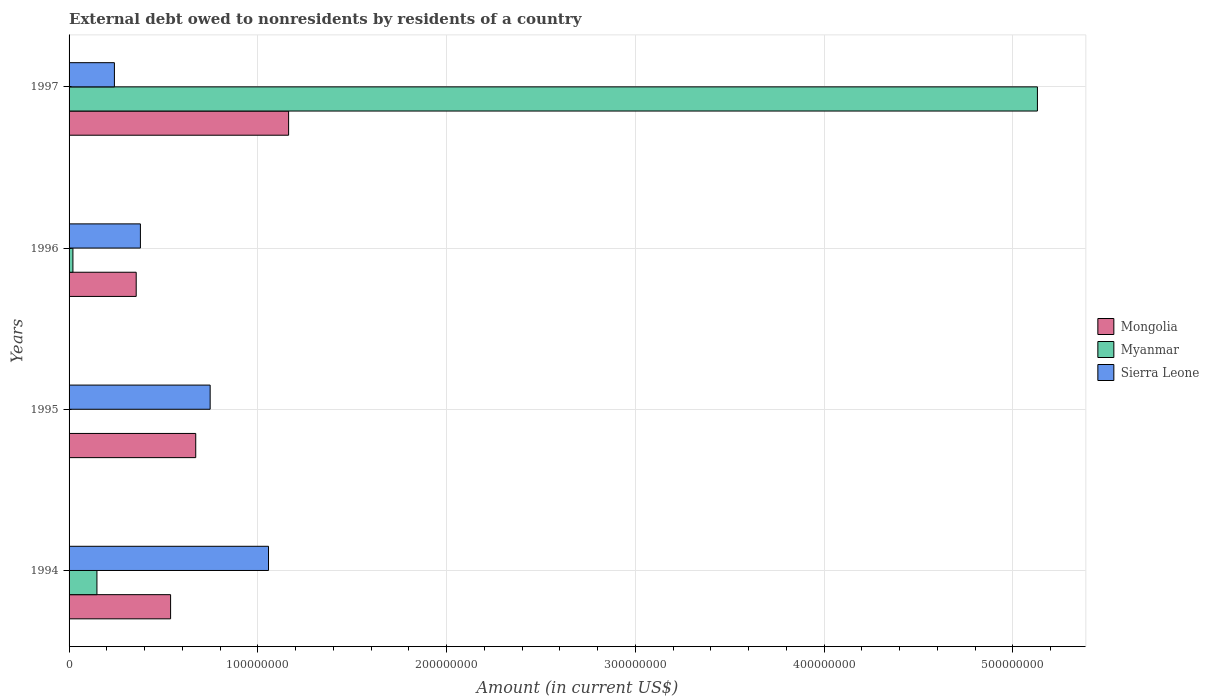How many different coloured bars are there?
Your answer should be compact. 3. What is the external debt owed by residents in Mongolia in 1994?
Give a very brief answer. 5.38e+07. Across all years, what is the maximum external debt owed by residents in Myanmar?
Provide a short and direct response. 5.13e+08. Across all years, what is the minimum external debt owed by residents in Mongolia?
Make the answer very short. 3.56e+07. What is the total external debt owed by residents in Myanmar in the graph?
Your answer should be very brief. 5.30e+08. What is the difference between the external debt owed by residents in Mongolia in 1995 and that in 1997?
Keep it short and to the point. -4.92e+07. What is the difference between the external debt owed by residents in Mongolia in 1996 and the external debt owed by residents in Myanmar in 1997?
Keep it short and to the point. -4.77e+08. What is the average external debt owed by residents in Mongolia per year?
Ensure brevity in your answer.  6.82e+07. In the year 1997, what is the difference between the external debt owed by residents in Sierra Leone and external debt owed by residents in Myanmar?
Provide a short and direct response. -4.89e+08. What is the ratio of the external debt owed by residents in Sierra Leone in 1995 to that in 1997?
Make the answer very short. 3.11. What is the difference between the highest and the second highest external debt owed by residents in Myanmar?
Keep it short and to the point. 4.98e+08. What is the difference between the highest and the lowest external debt owed by residents in Myanmar?
Offer a terse response. 5.13e+08. In how many years, is the external debt owed by residents in Mongolia greater than the average external debt owed by residents in Mongolia taken over all years?
Your response must be concise. 1. Is the sum of the external debt owed by residents in Myanmar in 1994 and 1997 greater than the maximum external debt owed by residents in Sierra Leone across all years?
Your answer should be compact. Yes. Is it the case that in every year, the sum of the external debt owed by residents in Mongolia and external debt owed by residents in Myanmar is greater than the external debt owed by residents in Sierra Leone?
Keep it short and to the point. No. How many bars are there?
Keep it short and to the point. 11. Are all the bars in the graph horizontal?
Make the answer very short. Yes. What is the difference between two consecutive major ticks on the X-axis?
Offer a terse response. 1.00e+08. Does the graph contain grids?
Your response must be concise. Yes. What is the title of the graph?
Offer a terse response. External debt owed to nonresidents by residents of a country. Does "South Sudan" appear as one of the legend labels in the graph?
Provide a succinct answer. No. What is the label or title of the X-axis?
Make the answer very short. Amount (in current US$). What is the label or title of the Y-axis?
Provide a succinct answer. Years. What is the Amount (in current US$) in Mongolia in 1994?
Your response must be concise. 5.38e+07. What is the Amount (in current US$) in Myanmar in 1994?
Offer a very short reply. 1.48e+07. What is the Amount (in current US$) of Sierra Leone in 1994?
Make the answer very short. 1.06e+08. What is the Amount (in current US$) in Mongolia in 1995?
Offer a very short reply. 6.71e+07. What is the Amount (in current US$) in Sierra Leone in 1995?
Your answer should be very brief. 7.47e+07. What is the Amount (in current US$) of Mongolia in 1996?
Your response must be concise. 3.56e+07. What is the Amount (in current US$) of Myanmar in 1996?
Offer a very short reply. 2.04e+06. What is the Amount (in current US$) in Sierra Leone in 1996?
Your response must be concise. 3.78e+07. What is the Amount (in current US$) of Mongolia in 1997?
Your answer should be very brief. 1.16e+08. What is the Amount (in current US$) of Myanmar in 1997?
Your answer should be very brief. 5.13e+08. What is the Amount (in current US$) of Sierra Leone in 1997?
Give a very brief answer. 2.40e+07. Across all years, what is the maximum Amount (in current US$) in Mongolia?
Your answer should be compact. 1.16e+08. Across all years, what is the maximum Amount (in current US$) in Myanmar?
Ensure brevity in your answer.  5.13e+08. Across all years, what is the maximum Amount (in current US$) in Sierra Leone?
Give a very brief answer. 1.06e+08. Across all years, what is the minimum Amount (in current US$) in Mongolia?
Offer a terse response. 3.56e+07. Across all years, what is the minimum Amount (in current US$) of Myanmar?
Offer a very short reply. 0. Across all years, what is the minimum Amount (in current US$) in Sierra Leone?
Provide a succinct answer. 2.40e+07. What is the total Amount (in current US$) of Mongolia in the graph?
Ensure brevity in your answer.  2.73e+08. What is the total Amount (in current US$) of Myanmar in the graph?
Offer a terse response. 5.30e+08. What is the total Amount (in current US$) in Sierra Leone in the graph?
Your response must be concise. 2.42e+08. What is the difference between the Amount (in current US$) of Mongolia in 1994 and that in 1995?
Give a very brief answer. -1.33e+07. What is the difference between the Amount (in current US$) of Sierra Leone in 1994 and that in 1995?
Offer a very short reply. 3.09e+07. What is the difference between the Amount (in current US$) in Mongolia in 1994 and that in 1996?
Make the answer very short. 1.82e+07. What is the difference between the Amount (in current US$) of Myanmar in 1994 and that in 1996?
Provide a short and direct response. 1.27e+07. What is the difference between the Amount (in current US$) of Sierra Leone in 1994 and that in 1996?
Provide a short and direct response. 6.79e+07. What is the difference between the Amount (in current US$) of Mongolia in 1994 and that in 1997?
Provide a succinct answer. -6.25e+07. What is the difference between the Amount (in current US$) of Myanmar in 1994 and that in 1997?
Offer a very short reply. -4.98e+08. What is the difference between the Amount (in current US$) in Sierra Leone in 1994 and that in 1997?
Keep it short and to the point. 8.16e+07. What is the difference between the Amount (in current US$) in Mongolia in 1995 and that in 1996?
Give a very brief answer. 3.15e+07. What is the difference between the Amount (in current US$) in Sierra Leone in 1995 and that in 1996?
Offer a very short reply. 3.69e+07. What is the difference between the Amount (in current US$) of Mongolia in 1995 and that in 1997?
Ensure brevity in your answer.  -4.92e+07. What is the difference between the Amount (in current US$) of Sierra Leone in 1995 and that in 1997?
Make the answer very short. 5.07e+07. What is the difference between the Amount (in current US$) of Mongolia in 1996 and that in 1997?
Make the answer very short. -8.07e+07. What is the difference between the Amount (in current US$) in Myanmar in 1996 and that in 1997?
Your answer should be very brief. -5.11e+08. What is the difference between the Amount (in current US$) of Sierra Leone in 1996 and that in 1997?
Your response must be concise. 1.38e+07. What is the difference between the Amount (in current US$) in Mongolia in 1994 and the Amount (in current US$) in Sierra Leone in 1995?
Provide a short and direct response. -2.10e+07. What is the difference between the Amount (in current US$) in Myanmar in 1994 and the Amount (in current US$) in Sierra Leone in 1995?
Ensure brevity in your answer.  -6.00e+07. What is the difference between the Amount (in current US$) of Mongolia in 1994 and the Amount (in current US$) of Myanmar in 1996?
Offer a terse response. 5.17e+07. What is the difference between the Amount (in current US$) of Mongolia in 1994 and the Amount (in current US$) of Sierra Leone in 1996?
Offer a terse response. 1.60e+07. What is the difference between the Amount (in current US$) of Myanmar in 1994 and the Amount (in current US$) of Sierra Leone in 1996?
Ensure brevity in your answer.  -2.30e+07. What is the difference between the Amount (in current US$) in Mongolia in 1994 and the Amount (in current US$) in Myanmar in 1997?
Keep it short and to the point. -4.59e+08. What is the difference between the Amount (in current US$) in Mongolia in 1994 and the Amount (in current US$) in Sierra Leone in 1997?
Ensure brevity in your answer.  2.98e+07. What is the difference between the Amount (in current US$) in Myanmar in 1994 and the Amount (in current US$) in Sierra Leone in 1997?
Provide a succinct answer. -9.25e+06. What is the difference between the Amount (in current US$) of Mongolia in 1995 and the Amount (in current US$) of Myanmar in 1996?
Your response must be concise. 6.51e+07. What is the difference between the Amount (in current US$) of Mongolia in 1995 and the Amount (in current US$) of Sierra Leone in 1996?
Offer a very short reply. 2.93e+07. What is the difference between the Amount (in current US$) in Mongolia in 1995 and the Amount (in current US$) in Myanmar in 1997?
Give a very brief answer. -4.46e+08. What is the difference between the Amount (in current US$) of Mongolia in 1995 and the Amount (in current US$) of Sierra Leone in 1997?
Provide a succinct answer. 4.31e+07. What is the difference between the Amount (in current US$) in Mongolia in 1996 and the Amount (in current US$) in Myanmar in 1997?
Make the answer very short. -4.77e+08. What is the difference between the Amount (in current US$) of Mongolia in 1996 and the Amount (in current US$) of Sierra Leone in 1997?
Your response must be concise. 1.15e+07. What is the difference between the Amount (in current US$) in Myanmar in 1996 and the Amount (in current US$) in Sierra Leone in 1997?
Provide a succinct answer. -2.20e+07. What is the average Amount (in current US$) of Mongolia per year?
Offer a terse response. 6.82e+07. What is the average Amount (in current US$) of Myanmar per year?
Keep it short and to the point. 1.32e+08. What is the average Amount (in current US$) in Sierra Leone per year?
Provide a short and direct response. 6.05e+07. In the year 1994, what is the difference between the Amount (in current US$) of Mongolia and Amount (in current US$) of Myanmar?
Offer a terse response. 3.90e+07. In the year 1994, what is the difference between the Amount (in current US$) of Mongolia and Amount (in current US$) of Sierra Leone?
Make the answer very short. -5.19e+07. In the year 1994, what is the difference between the Amount (in current US$) of Myanmar and Amount (in current US$) of Sierra Leone?
Make the answer very short. -9.09e+07. In the year 1995, what is the difference between the Amount (in current US$) in Mongolia and Amount (in current US$) in Sierra Leone?
Your answer should be very brief. -7.64e+06. In the year 1996, what is the difference between the Amount (in current US$) in Mongolia and Amount (in current US$) in Myanmar?
Keep it short and to the point. 3.35e+07. In the year 1996, what is the difference between the Amount (in current US$) in Mongolia and Amount (in current US$) in Sierra Leone?
Keep it short and to the point. -2.23e+06. In the year 1996, what is the difference between the Amount (in current US$) of Myanmar and Amount (in current US$) of Sierra Leone?
Give a very brief answer. -3.58e+07. In the year 1997, what is the difference between the Amount (in current US$) of Mongolia and Amount (in current US$) of Myanmar?
Provide a short and direct response. -3.97e+08. In the year 1997, what is the difference between the Amount (in current US$) in Mongolia and Amount (in current US$) in Sierra Leone?
Keep it short and to the point. 9.23e+07. In the year 1997, what is the difference between the Amount (in current US$) of Myanmar and Amount (in current US$) of Sierra Leone?
Your response must be concise. 4.89e+08. What is the ratio of the Amount (in current US$) of Mongolia in 1994 to that in 1995?
Keep it short and to the point. 0.8. What is the ratio of the Amount (in current US$) in Sierra Leone in 1994 to that in 1995?
Your response must be concise. 1.41. What is the ratio of the Amount (in current US$) of Mongolia in 1994 to that in 1996?
Keep it short and to the point. 1.51. What is the ratio of the Amount (in current US$) of Myanmar in 1994 to that in 1996?
Give a very brief answer. 7.23. What is the ratio of the Amount (in current US$) of Sierra Leone in 1994 to that in 1996?
Your answer should be very brief. 2.8. What is the ratio of the Amount (in current US$) in Mongolia in 1994 to that in 1997?
Provide a short and direct response. 0.46. What is the ratio of the Amount (in current US$) in Myanmar in 1994 to that in 1997?
Make the answer very short. 0.03. What is the ratio of the Amount (in current US$) in Sierra Leone in 1994 to that in 1997?
Offer a very short reply. 4.4. What is the ratio of the Amount (in current US$) in Mongolia in 1995 to that in 1996?
Ensure brevity in your answer.  1.89. What is the ratio of the Amount (in current US$) in Sierra Leone in 1995 to that in 1996?
Provide a succinct answer. 1.98. What is the ratio of the Amount (in current US$) in Mongolia in 1995 to that in 1997?
Provide a short and direct response. 0.58. What is the ratio of the Amount (in current US$) in Sierra Leone in 1995 to that in 1997?
Your answer should be very brief. 3.11. What is the ratio of the Amount (in current US$) in Mongolia in 1996 to that in 1997?
Your answer should be very brief. 0.31. What is the ratio of the Amount (in current US$) of Myanmar in 1996 to that in 1997?
Your answer should be compact. 0. What is the ratio of the Amount (in current US$) of Sierra Leone in 1996 to that in 1997?
Offer a terse response. 1.57. What is the difference between the highest and the second highest Amount (in current US$) in Mongolia?
Give a very brief answer. 4.92e+07. What is the difference between the highest and the second highest Amount (in current US$) of Myanmar?
Your answer should be very brief. 4.98e+08. What is the difference between the highest and the second highest Amount (in current US$) of Sierra Leone?
Keep it short and to the point. 3.09e+07. What is the difference between the highest and the lowest Amount (in current US$) of Mongolia?
Offer a very short reply. 8.07e+07. What is the difference between the highest and the lowest Amount (in current US$) of Myanmar?
Provide a succinct answer. 5.13e+08. What is the difference between the highest and the lowest Amount (in current US$) of Sierra Leone?
Make the answer very short. 8.16e+07. 